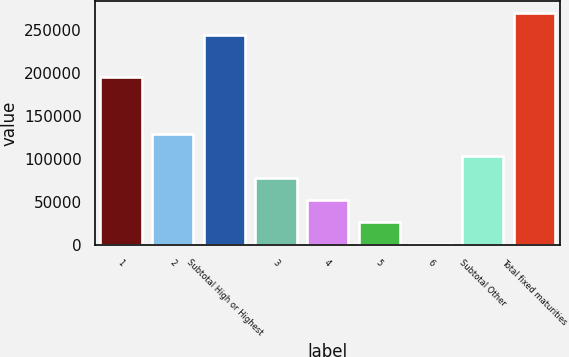Convert chart. <chart><loc_0><loc_0><loc_500><loc_500><bar_chart><fcel>1<fcel>2<fcel>Subtotal High or Highest<fcel>3<fcel>4<fcel>5<fcel>6<fcel>Subtotal Other<fcel>Total fixed maturities<nl><fcel>195279<fcel>128780<fcel>244565<fcel>77406.4<fcel>51719.6<fcel>26032.8<fcel>346<fcel>103093<fcel>270252<nl></chart> 